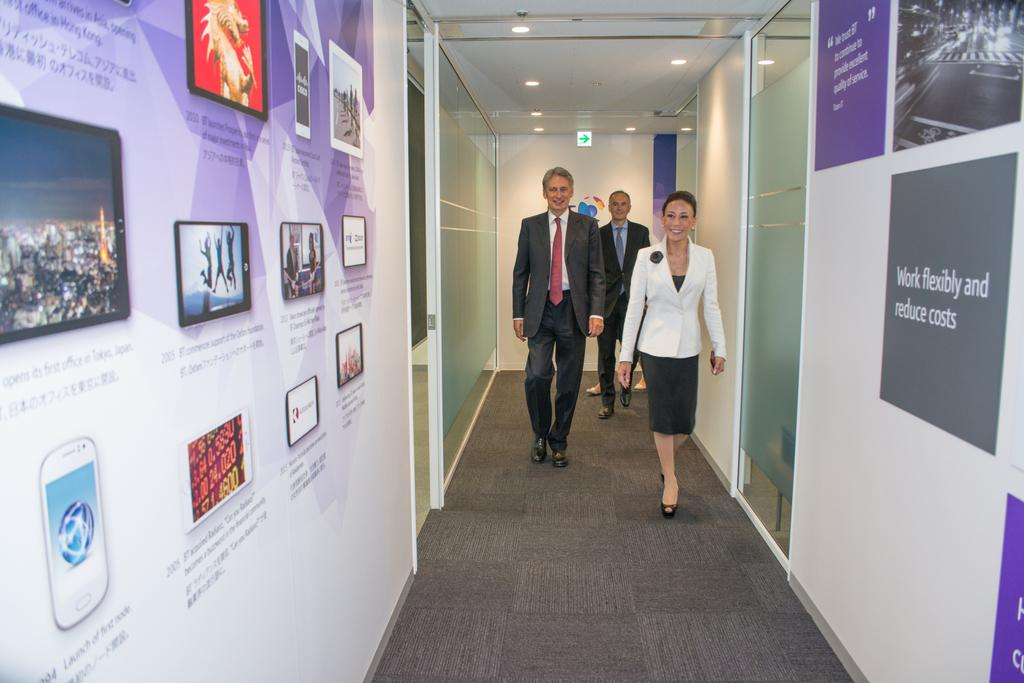<image>
Present a compact description of the photo's key features. Three business people stroll down a hallway lined with photos and a poster about working flexibly and reducing costs. 